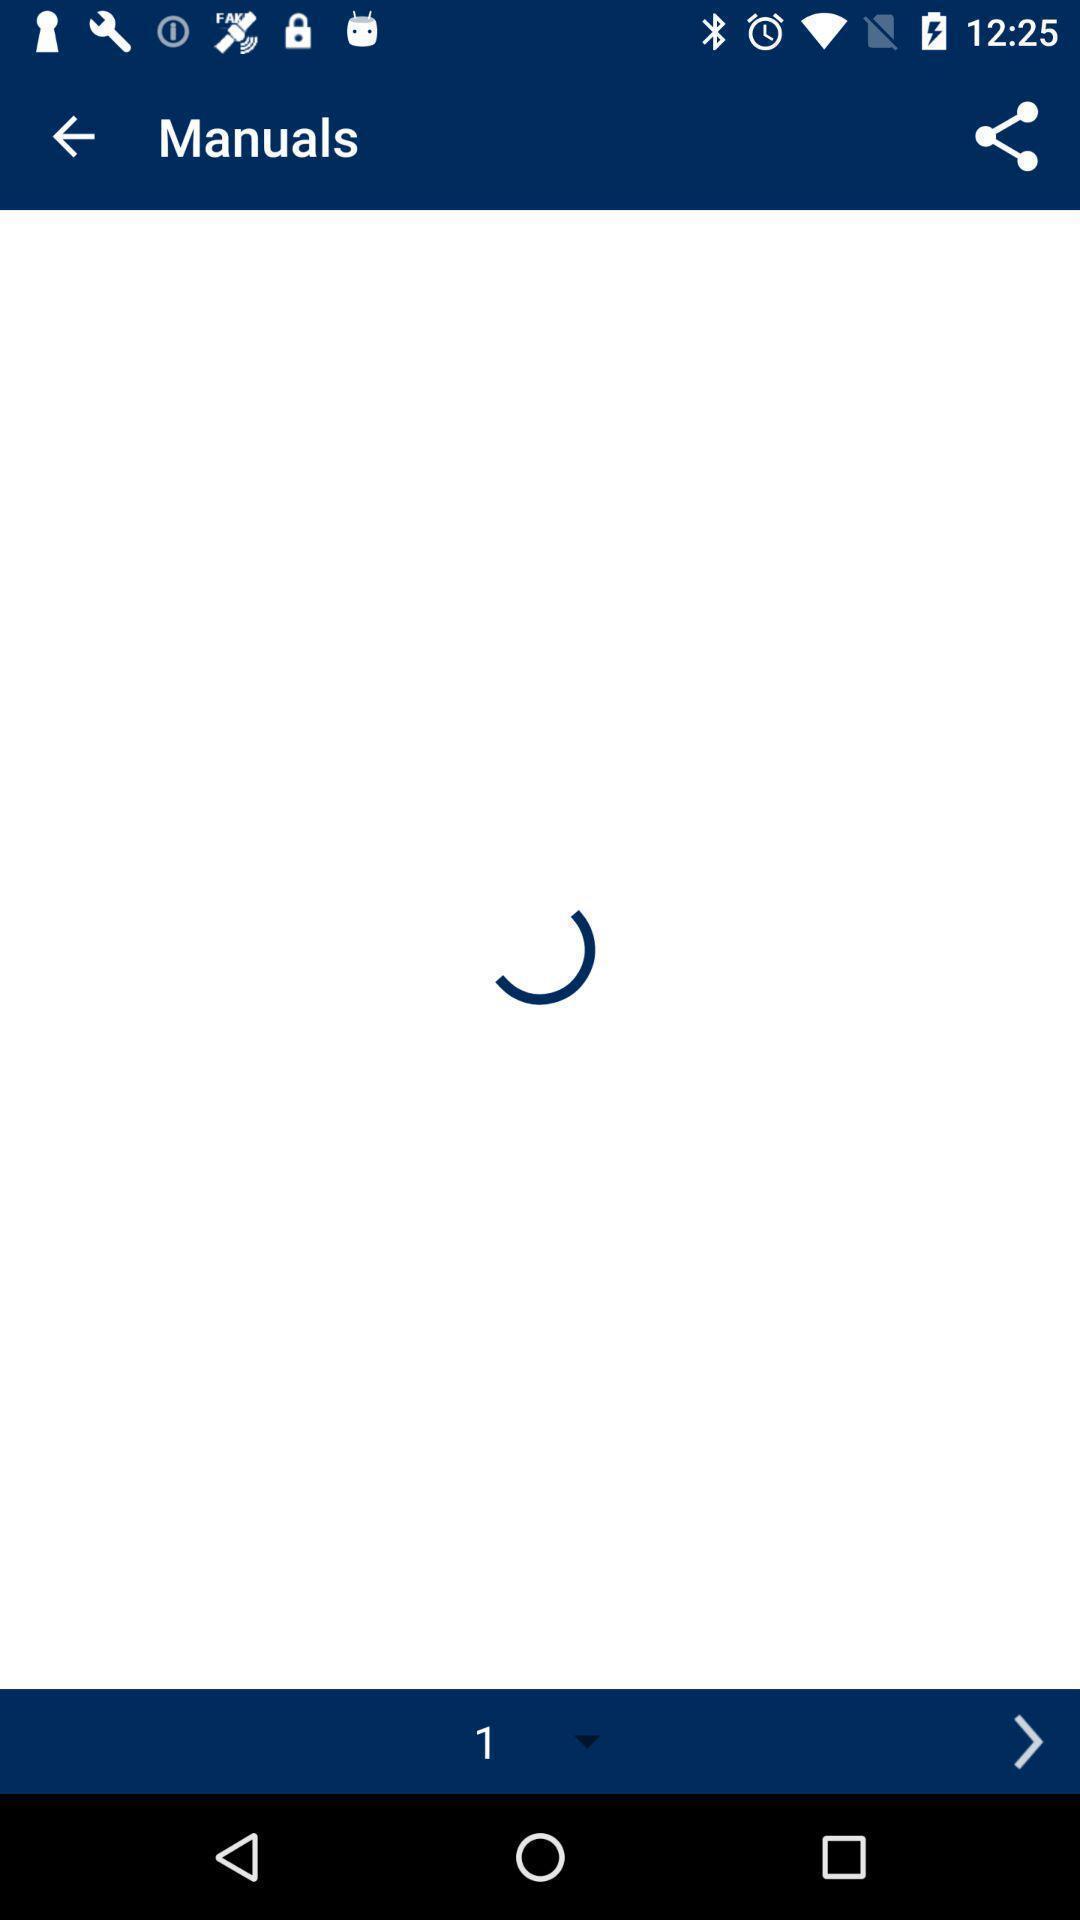What is the overall content of this screenshot? Page showing various options of app. 